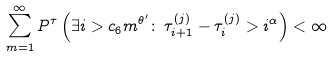<formula> <loc_0><loc_0><loc_500><loc_500>\sum _ { m = 1 } ^ { \infty } P ^ { \tau } \left ( \exists i > c _ { 6 } m ^ { \theta ^ { \prime } } \colon \, \tau _ { i + 1 } ^ { ( j ) } - \tau _ { i } ^ { ( j ) } > i ^ { \alpha } \right ) < \infty</formula> 